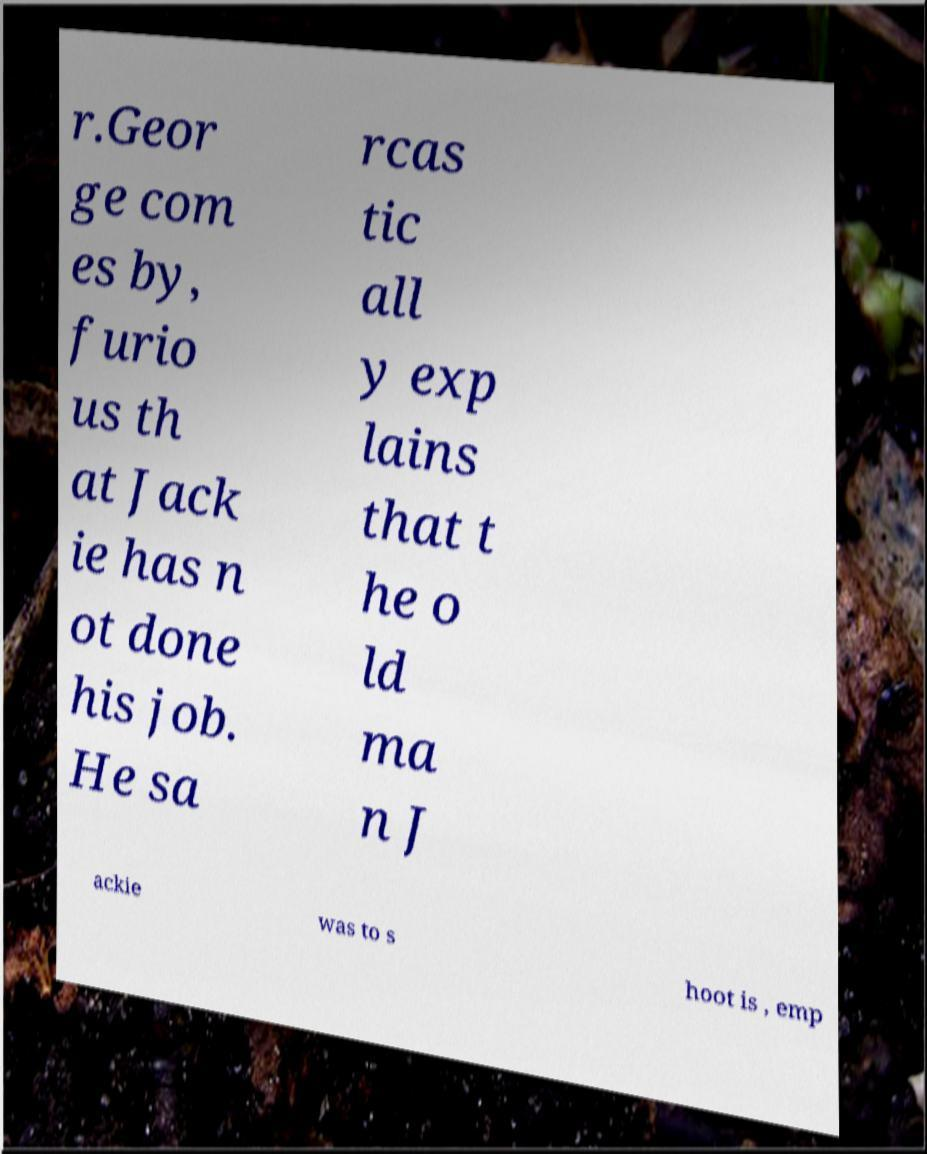Please identify and transcribe the text found in this image. r.Geor ge com es by, furio us th at Jack ie has n ot done his job. He sa rcas tic all y exp lains that t he o ld ma n J ackie was to s hoot is , emp 